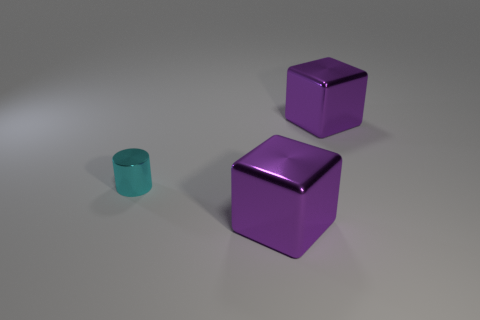Add 2 small cyan metal cylinders. How many objects exist? 5 Subtract all cylinders. How many objects are left? 2 Add 3 small cyan things. How many small cyan things exist? 4 Subtract 0 gray cylinders. How many objects are left? 3 Subtract all cylinders. Subtract all small metallic blocks. How many objects are left? 2 Add 2 big metal things. How many big metal things are left? 4 